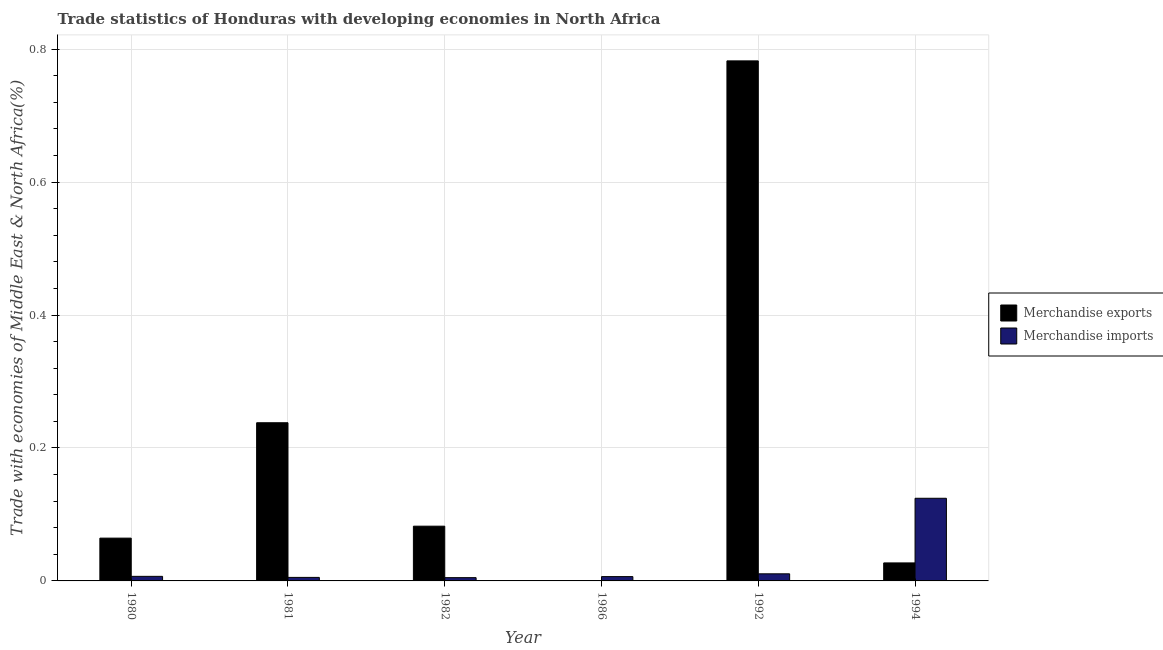How many groups of bars are there?
Ensure brevity in your answer.  6. Are the number of bars on each tick of the X-axis equal?
Your answer should be compact. Yes. How many bars are there on the 6th tick from the left?
Your answer should be very brief. 2. How many bars are there on the 3rd tick from the right?
Give a very brief answer. 2. What is the label of the 4th group of bars from the left?
Offer a very short reply. 1986. What is the merchandise exports in 1981?
Your response must be concise. 0.24. Across all years, what is the maximum merchandise imports?
Your answer should be compact. 0.12. Across all years, what is the minimum merchandise imports?
Your answer should be very brief. 0. In which year was the merchandise exports minimum?
Make the answer very short. 1986. What is the total merchandise exports in the graph?
Keep it short and to the point. 1.19. What is the difference between the merchandise imports in 1982 and that in 1994?
Provide a short and direct response. -0.12. What is the difference between the merchandise imports in 1986 and the merchandise exports in 1992?
Make the answer very short. -0. What is the average merchandise imports per year?
Provide a short and direct response. 0.03. In the year 1981, what is the difference between the merchandise exports and merchandise imports?
Offer a very short reply. 0. In how many years, is the merchandise imports greater than 0.16 %?
Give a very brief answer. 0. What is the ratio of the merchandise imports in 1982 to that in 1994?
Make the answer very short. 0.04. Is the merchandise exports in 1980 less than that in 1981?
Keep it short and to the point. Yes. What is the difference between the highest and the second highest merchandise imports?
Your response must be concise. 0.11. What is the difference between the highest and the lowest merchandise exports?
Offer a very short reply. 0.78. In how many years, is the merchandise imports greater than the average merchandise imports taken over all years?
Offer a very short reply. 1. Is the sum of the merchandise imports in 1981 and 1992 greater than the maximum merchandise exports across all years?
Make the answer very short. No. What does the 1st bar from the left in 1994 represents?
Keep it short and to the point. Merchandise exports. How many bars are there?
Provide a short and direct response. 12. What is the difference between two consecutive major ticks on the Y-axis?
Your response must be concise. 0.2. Does the graph contain grids?
Offer a very short reply. Yes. What is the title of the graph?
Your answer should be very brief. Trade statistics of Honduras with developing economies in North Africa. Does "Study and work" appear as one of the legend labels in the graph?
Your answer should be compact. No. What is the label or title of the X-axis?
Offer a terse response. Year. What is the label or title of the Y-axis?
Provide a succinct answer. Trade with economies of Middle East & North Africa(%). What is the Trade with economies of Middle East & North Africa(%) of Merchandise exports in 1980?
Keep it short and to the point. 0.06. What is the Trade with economies of Middle East & North Africa(%) in Merchandise imports in 1980?
Your response must be concise. 0.01. What is the Trade with economies of Middle East & North Africa(%) of Merchandise exports in 1981?
Give a very brief answer. 0.24. What is the Trade with economies of Middle East & North Africa(%) in Merchandise imports in 1981?
Ensure brevity in your answer.  0.01. What is the Trade with economies of Middle East & North Africa(%) in Merchandise exports in 1982?
Your response must be concise. 0.08. What is the Trade with economies of Middle East & North Africa(%) in Merchandise imports in 1982?
Offer a terse response. 0. What is the Trade with economies of Middle East & North Africa(%) of Merchandise exports in 1986?
Give a very brief answer. 0. What is the Trade with economies of Middle East & North Africa(%) of Merchandise imports in 1986?
Offer a terse response. 0.01. What is the Trade with economies of Middle East & North Africa(%) of Merchandise exports in 1992?
Offer a very short reply. 0.78. What is the Trade with economies of Middle East & North Africa(%) of Merchandise imports in 1992?
Your answer should be very brief. 0.01. What is the Trade with economies of Middle East & North Africa(%) in Merchandise exports in 1994?
Make the answer very short. 0.03. What is the Trade with economies of Middle East & North Africa(%) in Merchandise imports in 1994?
Provide a succinct answer. 0.12. Across all years, what is the maximum Trade with economies of Middle East & North Africa(%) in Merchandise exports?
Offer a terse response. 0.78. Across all years, what is the maximum Trade with economies of Middle East & North Africa(%) in Merchandise imports?
Your response must be concise. 0.12. Across all years, what is the minimum Trade with economies of Middle East & North Africa(%) of Merchandise exports?
Offer a very short reply. 0. Across all years, what is the minimum Trade with economies of Middle East & North Africa(%) in Merchandise imports?
Offer a terse response. 0. What is the total Trade with economies of Middle East & North Africa(%) of Merchandise exports in the graph?
Your response must be concise. 1.19. What is the total Trade with economies of Middle East & North Africa(%) in Merchandise imports in the graph?
Offer a very short reply. 0.16. What is the difference between the Trade with economies of Middle East & North Africa(%) of Merchandise exports in 1980 and that in 1981?
Offer a very short reply. -0.17. What is the difference between the Trade with economies of Middle East & North Africa(%) of Merchandise imports in 1980 and that in 1981?
Provide a short and direct response. 0. What is the difference between the Trade with economies of Middle East & North Africa(%) in Merchandise exports in 1980 and that in 1982?
Keep it short and to the point. -0.02. What is the difference between the Trade with economies of Middle East & North Africa(%) in Merchandise imports in 1980 and that in 1982?
Ensure brevity in your answer.  0. What is the difference between the Trade with economies of Middle East & North Africa(%) of Merchandise exports in 1980 and that in 1986?
Your answer should be compact. 0.06. What is the difference between the Trade with economies of Middle East & North Africa(%) of Merchandise imports in 1980 and that in 1986?
Make the answer very short. 0. What is the difference between the Trade with economies of Middle East & North Africa(%) in Merchandise exports in 1980 and that in 1992?
Your answer should be compact. -0.72. What is the difference between the Trade with economies of Middle East & North Africa(%) of Merchandise imports in 1980 and that in 1992?
Make the answer very short. -0. What is the difference between the Trade with economies of Middle East & North Africa(%) of Merchandise exports in 1980 and that in 1994?
Your answer should be compact. 0.04. What is the difference between the Trade with economies of Middle East & North Africa(%) in Merchandise imports in 1980 and that in 1994?
Give a very brief answer. -0.12. What is the difference between the Trade with economies of Middle East & North Africa(%) of Merchandise exports in 1981 and that in 1982?
Your answer should be compact. 0.16. What is the difference between the Trade with economies of Middle East & North Africa(%) in Merchandise exports in 1981 and that in 1986?
Give a very brief answer. 0.24. What is the difference between the Trade with economies of Middle East & North Africa(%) in Merchandise imports in 1981 and that in 1986?
Your response must be concise. -0. What is the difference between the Trade with economies of Middle East & North Africa(%) in Merchandise exports in 1981 and that in 1992?
Your answer should be very brief. -0.54. What is the difference between the Trade with economies of Middle East & North Africa(%) of Merchandise imports in 1981 and that in 1992?
Give a very brief answer. -0.01. What is the difference between the Trade with economies of Middle East & North Africa(%) in Merchandise exports in 1981 and that in 1994?
Ensure brevity in your answer.  0.21. What is the difference between the Trade with economies of Middle East & North Africa(%) of Merchandise imports in 1981 and that in 1994?
Keep it short and to the point. -0.12. What is the difference between the Trade with economies of Middle East & North Africa(%) in Merchandise exports in 1982 and that in 1986?
Offer a terse response. 0.08. What is the difference between the Trade with economies of Middle East & North Africa(%) of Merchandise imports in 1982 and that in 1986?
Your answer should be compact. -0. What is the difference between the Trade with economies of Middle East & North Africa(%) of Merchandise exports in 1982 and that in 1992?
Provide a succinct answer. -0.7. What is the difference between the Trade with economies of Middle East & North Africa(%) of Merchandise imports in 1982 and that in 1992?
Your answer should be compact. -0.01. What is the difference between the Trade with economies of Middle East & North Africa(%) in Merchandise exports in 1982 and that in 1994?
Your answer should be compact. 0.06. What is the difference between the Trade with economies of Middle East & North Africa(%) in Merchandise imports in 1982 and that in 1994?
Offer a very short reply. -0.12. What is the difference between the Trade with economies of Middle East & North Africa(%) in Merchandise exports in 1986 and that in 1992?
Make the answer very short. -0.78. What is the difference between the Trade with economies of Middle East & North Africa(%) of Merchandise imports in 1986 and that in 1992?
Offer a terse response. -0. What is the difference between the Trade with economies of Middle East & North Africa(%) in Merchandise exports in 1986 and that in 1994?
Your response must be concise. -0.03. What is the difference between the Trade with economies of Middle East & North Africa(%) in Merchandise imports in 1986 and that in 1994?
Your response must be concise. -0.12. What is the difference between the Trade with economies of Middle East & North Africa(%) in Merchandise exports in 1992 and that in 1994?
Provide a short and direct response. 0.76. What is the difference between the Trade with economies of Middle East & North Africa(%) in Merchandise imports in 1992 and that in 1994?
Offer a very short reply. -0.11. What is the difference between the Trade with economies of Middle East & North Africa(%) of Merchandise exports in 1980 and the Trade with economies of Middle East & North Africa(%) of Merchandise imports in 1981?
Keep it short and to the point. 0.06. What is the difference between the Trade with economies of Middle East & North Africa(%) in Merchandise exports in 1980 and the Trade with economies of Middle East & North Africa(%) in Merchandise imports in 1982?
Your answer should be very brief. 0.06. What is the difference between the Trade with economies of Middle East & North Africa(%) in Merchandise exports in 1980 and the Trade with economies of Middle East & North Africa(%) in Merchandise imports in 1986?
Your answer should be compact. 0.06. What is the difference between the Trade with economies of Middle East & North Africa(%) in Merchandise exports in 1980 and the Trade with economies of Middle East & North Africa(%) in Merchandise imports in 1992?
Provide a short and direct response. 0.05. What is the difference between the Trade with economies of Middle East & North Africa(%) in Merchandise exports in 1980 and the Trade with economies of Middle East & North Africa(%) in Merchandise imports in 1994?
Provide a short and direct response. -0.06. What is the difference between the Trade with economies of Middle East & North Africa(%) in Merchandise exports in 1981 and the Trade with economies of Middle East & North Africa(%) in Merchandise imports in 1982?
Ensure brevity in your answer.  0.23. What is the difference between the Trade with economies of Middle East & North Africa(%) of Merchandise exports in 1981 and the Trade with economies of Middle East & North Africa(%) of Merchandise imports in 1986?
Offer a terse response. 0.23. What is the difference between the Trade with economies of Middle East & North Africa(%) of Merchandise exports in 1981 and the Trade with economies of Middle East & North Africa(%) of Merchandise imports in 1992?
Your answer should be compact. 0.23. What is the difference between the Trade with economies of Middle East & North Africa(%) in Merchandise exports in 1981 and the Trade with economies of Middle East & North Africa(%) in Merchandise imports in 1994?
Your response must be concise. 0.11. What is the difference between the Trade with economies of Middle East & North Africa(%) of Merchandise exports in 1982 and the Trade with economies of Middle East & North Africa(%) of Merchandise imports in 1986?
Give a very brief answer. 0.08. What is the difference between the Trade with economies of Middle East & North Africa(%) in Merchandise exports in 1982 and the Trade with economies of Middle East & North Africa(%) in Merchandise imports in 1992?
Your response must be concise. 0.07. What is the difference between the Trade with economies of Middle East & North Africa(%) of Merchandise exports in 1982 and the Trade with economies of Middle East & North Africa(%) of Merchandise imports in 1994?
Ensure brevity in your answer.  -0.04. What is the difference between the Trade with economies of Middle East & North Africa(%) of Merchandise exports in 1986 and the Trade with economies of Middle East & North Africa(%) of Merchandise imports in 1992?
Give a very brief answer. -0.01. What is the difference between the Trade with economies of Middle East & North Africa(%) of Merchandise exports in 1986 and the Trade with economies of Middle East & North Africa(%) of Merchandise imports in 1994?
Your answer should be compact. -0.12. What is the difference between the Trade with economies of Middle East & North Africa(%) in Merchandise exports in 1992 and the Trade with economies of Middle East & North Africa(%) in Merchandise imports in 1994?
Make the answer very short. 0.66. What is the average Trade with economies of Middle East & North Africa(%) in Merchandise exports per year?
Ensure brevity in your answer.  0.2. What is the average Trade with economies of Middle East & North Africa(%) in Merchandise imports per year?
Your response must be concise. 0.03. In the year 1980, what is the difference between the Trade with economies of Middle East & North Africa(%) in Merchandise exports and Trade with economies of Middle East & North Africa(%) in Merchandise imports?
Provide a short and direct response. 0.06. In the year 1981, what is the difference between the Trade with economies of Middle East & North Africa(%) of Merchandise exports and Trade with economies of Middle East & North Africa(%) of Merchandise imports?
Make the answer very short. 0.23. In the year 1982, what is the difference between the Trade with economies of Middle East & North Africa(%) of Merchandise exports and Trade with economies of Middle East & North Africa(%) of Merchandise imports?
Ensure brevity in your answer.  0.08. In the year 1986, what is the difference between the Trade with economies of Middle East & North Africa(%) in Merchandise exports and Trade with economies of Middle East & North Africa(%) in Merchandise imports?
Offer a very short reply. -0.01. In the year 1992, what is the difference between the Trade with economies of Middle East & North Africa(%) of Merchandise exports and Trade with economies of Middle East & North Africa(%) of Merchandise imports?
Provide a short and direct response. 0.77. In the year 1994, what is the difference between the Trade with economies of Middle East & North Africa(%) of Merchandise exports and Trade with economies of Middle East & North Africa(%) of Merchandise imports?
Offer a very short reply. -0.1. What is the ratio of the Trade with economies of Middle East & North Africa(%) of Merchandise exports in 1980 to that in 1981?
Make the answer very short. 0.27. What is the ratio of the Trade with economies of Middle East & North Africa(%) of Merchandise imports in 1980 to that in 1981?
Keep it short and to the point. 1.3. What is the ratio of the Trade with economies of Middle East & North Africa(%) of Merchandise exports in 1980 to that in 1982?
Provide a short and direct response. 0.78. What is the ratio of the Trade with economies of Middle East & North Africa(%) in Merchandise imports in 1980 to that in 1982?
Provide a succinct answer. 1.4. What is the ratio of the Trade with economies of Middle East & North Africa(%) of Merchandise exports in 1980 to that in 1986?
Your answer should be very brief. 496.93. What is the ratio of the Trade with economies of Middle East & North Africa(%) in Merchandise imports in 1980 to that in 1986?
Provide a short and direct response. 1.06. What is the ratio of the Trade with economies of Middle East & North Africa(%) in Merchandise exports in 1980 to that in 1992?
Keep it short and to the point. 0.08. What is the ratio of the Trade with economies of Middle East & North Africa(%) of Merchandise imports in 1980 to that in 1992?
Your response must be concise. 0.64. What is the ratio of the Trade with economies of Middle East & North Africa(%) of Merchandise exports in 1980 to that in 1994?
Your answer should be very brief. 2.38. What is the ratio of the Trade with economies of Middle East & North Africa(%) of Merchandise imports in 1980 to that in 1994?
Keep it short and to the point. 0.06. What is the ratio of the Trade with economies of Middle East & North Africa(%) of Merchandise exports in 1981 to that in 1982?
Your answer should be compact. 2.89. What is the ratio of the Trade with economies of Middle East & North Africa(%) of Merchandise imports in 1981 to that in 1982?
Keep it short and to the point. 1.08. What is the ratio of the Trade with economies of Middle East & North Africa(%) of Merchandise exports in 1981 to that in 1986?
Your response must be concise. 1836.87. What is the ratio of the Trade with economies of Middle East & North Africa(%) in Merchandise imports in 1981 to that in 1986?
Your answer should be compact. 0.82. What is the ratio of the Trade with economies of Middle East & North Africa(%) of Merchandise exports in 1981 to that in 1992?
Provide a short and direct response. 0.3. What is the ratio of the Trade with economies of Middle East & North Africa(%) in Merchandise imports in 1981 to that in 1992?
Your answer should be very brief. 0.5. What is the ratio of the Trade with economies of Middle East & North Africa(%) of Merchandise exports in 1981 to that in 1994?
Offer a very short reply. 8.79. What is the ratio of the Trade with economies of Middle East & North Africa(%) in Merchandise imports in 1981 to that in 1994?
Your answer should be compact. 0.04. What is the ratio of the Trade with economies of Middle East & North Africa(%) of Merchandise exports in 1982 to that in 1986?
Offer a very short reply. 635.73. What is the ratio of the Trade with economies of Middle East & North Africa(%) of Merchandise imports in 1982 to that in 1986?
Your response must be concise. 0.76. What is the ratio of the Trade with economies of Middle East & North Africa(%) in Merchandise exports in 1982 to that in 1992?
Keep it short and to the point. 0.11. What is the ratio of the Trade with economies of Middle East & North Africa(%) of Merchandise imports in 1982 to that in 1992?
Provide a short and direct response. 0.46. What is the ratio of the Trade with economies of Middle East & North Africa(%) of Merchandise exports in 1982 to that in 1994?
Offer a very short reply. 3.04. What is the ratio of the Trade with economies of Middle East & North Africa(%) in Merchandise imports in 1982 to that in 1994?
Provide a succinct answer. 0.04. What is the ratio of the Trade with economies of Middle East & North Africa(%) of Merchandise exports in 1986 to that in 1992?
Provide a short and direct response. 0. What is the ratio of the Trade with economies of Middle East & North Africa(%) of Merchandise imports in 1986 to that in 1992?
Offer a terse response. 0.61. What is the ratio of the Trade with economies of Middle East & North Africa(%) of Merchandise exports in 1986 to that in 1994?
Ensure brevity in your answer.  0. What is the ratio of the Trade with economies of Middle East & North Africa(%) of Merchandise imports in 1986 to that in 1994?
Provide a short and direct response. 0.05. What is the ratio of the Trade with economies of Middle East & North Africa(%) of Merchandise exports in 1992 to that in 1994?
Make the answer very short. 28.89. What is the ratio of the Trade with economies of Middle East & North Africa(%) of Merchandise imports in 1992 to that in 1994?
Offer a very short reply. 0.09. What is the difference between the highest and the second highest Trade with economies of Middle East & North Africa(%) of Merchandise exports?
Make the answer very short. 0.54. What is the difference between the highest and the second highest Trade with economies of Middle East & North Africa(%) in Merchandise imports?
Keep it short and to the point. 0.11. What is the difference between the highest and the lowest Trade with economies of Middle East & North Africa(%) in Merchandise exports?
Offer a very short reply. 0.78. What is the difference between the highest and the lowest Trade with economies of Middle East & North Africa(%) in Merchandise imports?
Your answer should be compact. 0.12. 